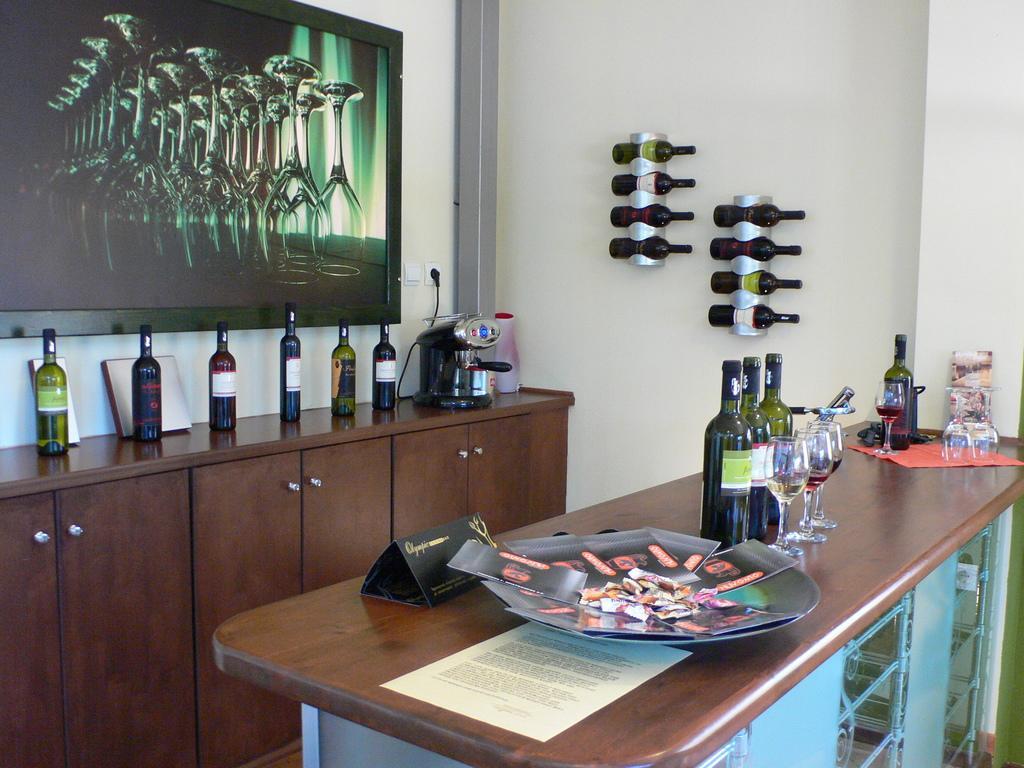Could you give a brief overview of what you see in this image? there is a table present on which there are glass bottles, glasses. behind that there are cupboards. above that there are other bottles. behind that there is a photo frame. and at the right there are bottles 